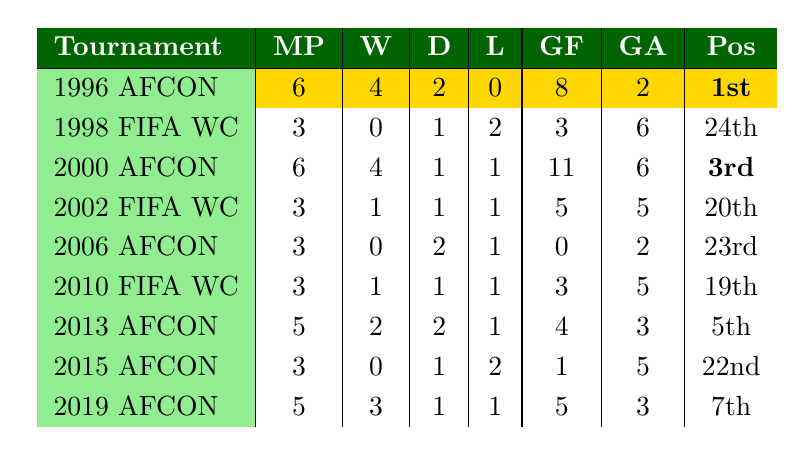What was Bafana Bafana's best performance in major international tournaments since 1996? Looking at the final positions listed in the table, Bafana Bafana achieved 1st place in the 1996 Africa Cup of Nations, which is the highest ranking among all entries.
Answer: 1st place in 1996 Africa Cup of Nations How many matches did Bafana Bafana win in the 2000 Africa Cup of Nations? The table shows that Bafana Bafana won 4 matches during the 2000 Africa Cup of Nations.
Answer: 4 wins What is the total number of matches Bafana Bafana played in all tournaments listed? Summing the matches played: 6 + 3 + 6 + 3 + 3 + 3 + 5 + 3 + 5 = 38.
Answer: 38 matches Did Bafana Bafana ever finish in 23rd place in any tournament? The table shows they finished in 23rd place in the 2006 Africa Cup of Nations, confirming it as true.
Answer: Yes How many goals did Bafana Bafana score across all tournaments combined? The sum of all goals scored: 8 + 3 + 11 + 5 + 0 + 3 + 4 + 1 + 5 = 40.
Answer: 40 goals In which tournament did Bafana Bafana achieve their highest goals scored in a single tournament? The data shows the highest goals scored was 11 in the 2000 Africa Cup of Nations.
Answer: 2000 Africa Cup of Nations What was the average final position of Bafana Bafana in the tournaments listed? Adding the final positions: 1 + 24 + 3 + 20 + 23 + 19 + 5 + 22 + 7 = 124. Then divide by 9: 124 / 9 = approximately 13.78.
Answer: Approximately 13.78 Which tournament had the most matches played by Bafana Bafana? The maximum matches played in a tournament is 6, which occurred in both the 1996 and 2000 Africa Cup of Nations.
Answer: 1996 and 2000 Africa Cup of Nations What was Bafana Bafana's goal difference in the 2013 Africa Cup of Nations? In the 2013 tournament, they scored 4 goals and conceded 3 goals, leading to a goal difference of 4 - 3 = 1.
Answer: 1 How many tournaments did Bafana Bafana finish in a position higher than 20th place? Bafana Bafana finished higher than 20th in the 1996 (1st), 2000 (3rd), 2013 (5th), and 2019 (7th) tournaments, totaling 4 tournaments.
Answer: 4 tournaments 